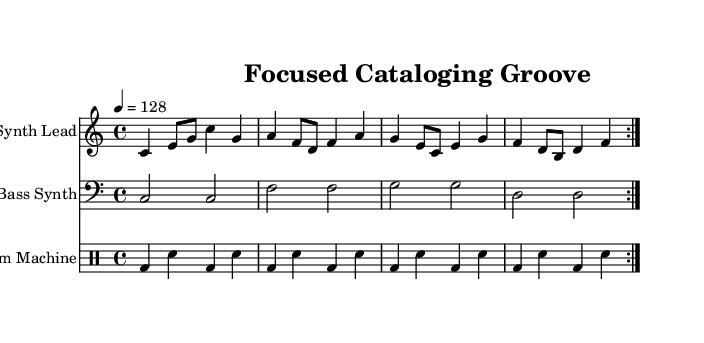What is the key signature of this music? The key signature is C major, which has no sharps or flats.
Answer: C major What is the time signature of this music? The time signature indicates that there are four beats in a measure, as shown by the 4/4 notation at the beginning of the score.
Answer: 4/4 What is the tempo marking for this piece? The tempo marking shows that the piece should be played at a speed of 128 beats per minute, noted at the beginning with "4 = 128".
Answer: 128 What instruments are used in this score? The instruments present in this score are the Synth Lead, Bass Synth, and Drum Machine, which are labeled at the beginning of each staff.
Answer: Synth Lead, Bass Synth, Drum Machine How many measures are repeated in the melody? The melody section is marked to repeat two times, as indicated by the "volta 2" at the beginning of the Synth Lead part, which means the measures within the repeat section will be played twice.
Answer: 2 What type of rhythm pattern is predominant in the drum section? The drum section features a consistent alternating pattern of bass drums and snare hits, maintaining the dance music rhythm typical for energetic pieces.
Answer: Alternating bass and snare What type of electronic sound is represented by the bass line? The bass line represents a synthesized bass sound, commonly used in dance music for its deep, resonant quality, which enhances the groove of the piece.
Answer: Synthesized bass 